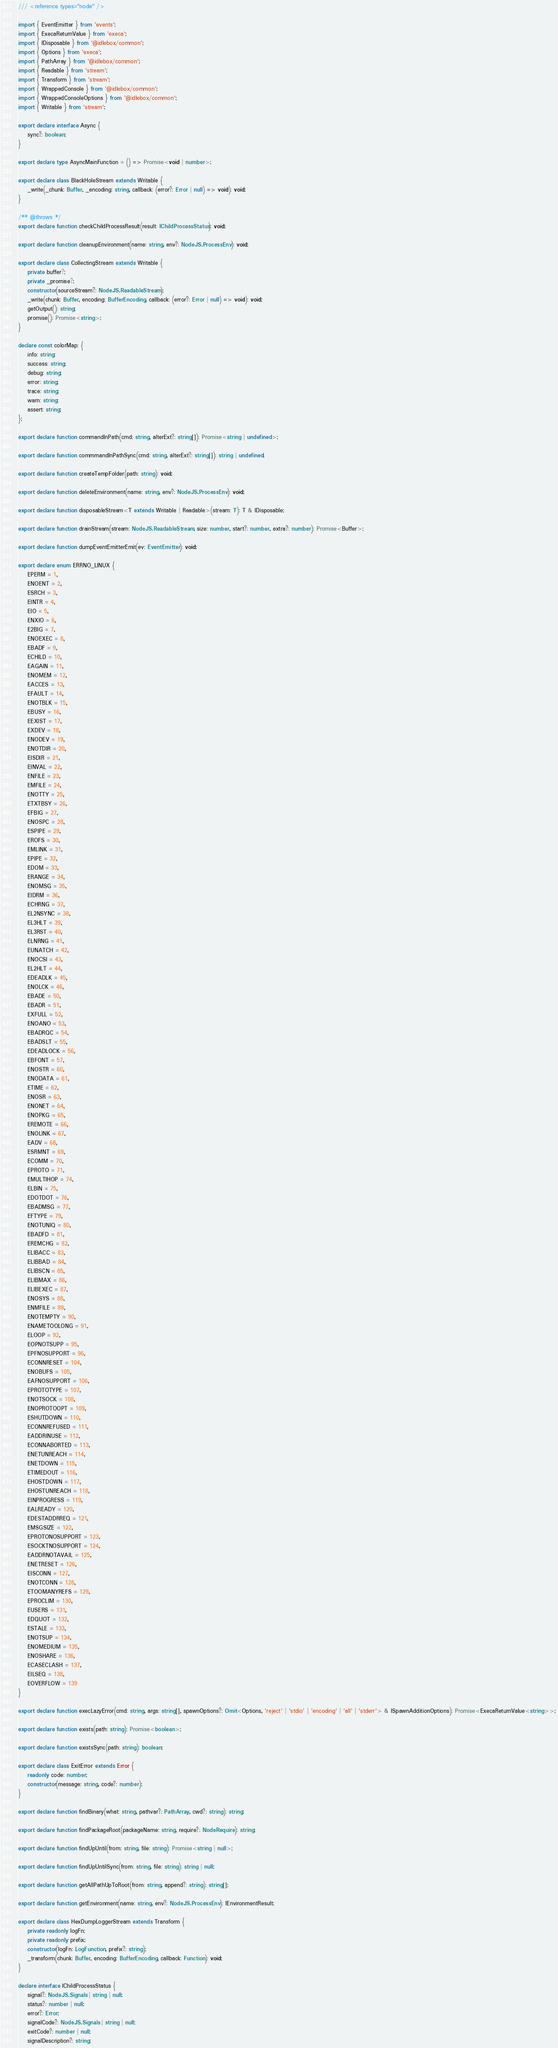Convert code to text. <code><loc_0><loc_0><loc_500><loc_500><_TypeScript_>/// <reference types="node" />

import { EventEmitter } from 'events';
import { ExecaReturnValue } from 'execa';
import { IDisposable } from '@idlebox/common';
import { Options } from 'execa';
import { PathArray } from '@idlebox/common';
import { Readable } from 'stream';
import { Transform } from 'stream';
import { WrappedConsole } from '@idlebox/common';
import { WrappedConsoleOptions } from '@idlebox/common';
import { Writable } from 'stream';

export declare interface Async {
    sync?: boolean;
}

export declare type AsyncMainFunction = () => Promise<void | number>;

export declare class BlackHoleStream extends Writable {
    _write(_chunk: Buffer, _encoding: string, callback: (error?: Error | null) => void): void;
}

/** @throws */
export declare function checkChildProcessResult(result: IChildProcessStatus): void;

export declare function cleanupEnvironment(name: string, env?: NodeJS.ProcessEnv): void;

export declare class CollectingStream extends Writable {
    private buffer?;
    private _promise?;
    constructor(sourceStream?: NodeJS.ReadableStream);
    _write(chunk: Buffer, encoding: BufferEncoding, callback: (error?: Error | null) => void): void;
    getOutput(): string;
    promise(): Promise<string>;
}

declare const colorMap: {
    info: string;
    success: string;
    debug: string;
    error: string;
    trace: string;
    warn: string;
    assert: string;
};

export declare function commandInPath(cmd: string, alterExt?: string[]): Promise<string | undefined>;

export declare function commmandInPathSync(cmd: string, alterExt?: string[]): string | undefined;

export declare function createTempFolder(path: string): void;

export declare function deleteEnvironment(name: string, env?: NodeJS.ProcessEnv): void;

export declare function disposableStream<T extends Writable | Readable>(stream: T): T & IDisposable;

export declare function drainStream(stream: NodeJS.ReadableStream, size: number, start?: number, extra?: number): Promise<Buffer>;

export declare function dumpEventEmitterEmit(ev: EventEmitter): void;

export declare enum ERRNO_LINUX {
    EPERM = 1,
    ENOENT = 2,
    ESRCH = 3,
    EINTR = 4,
    EIO = 5,
    ENXIO = 6,
    E2BIG = 7,
    ENOEXEC = 8,
    EBADF = 9,
    ECHILD = 10,
    EAGAIN = 11,
    ENOMEM = 12,
    EACCES = 13,
    EFAULT = 14,
    ENOTBLK = 15,
    EBUSY = 16,
    EEXIST = 17,
    EXDEV = 18,
    ENODEV = 19,
    ENOTDIR = 20,
    EISDIR = 21,
    EINVAL = 22,
    ENFILE = 23,
    EMFILE = 24,
    ENOTTY = 25,
    ETXTBSY = 26,
    EFBIG = 27,
    ENOSPC = 28,
    ESPIPE = 29,
    EROFS = 30,
    EMLINK = 31,
    EPIPE = 32,
    EDOM = 33,
    ERANGE = 34,
    ENOMSG = 35,
    EIDRM = 36,
    ECHRNG = 37,
    EL2NSYNC = 38,
    EL3HLT = 39,
    EL3RST = 40,
    ELNRNG = 41,
    EUNATCH = 42,
    ENOCSI = 43,
    EL2HLT = 44,
    EDEADLK = 45,
    ENOLCK = 46,
    EBADE = 50,
    EBADR = 51,
    EXFULL = 52,
    ENOANO = 53,
    EBADRQC = 54,
    EBADSLT = 55,
    EDEADLOCK = 56,
    EBFONT = 57,
    ENOSTR = 60,
    ENODATA = 61,
    ETIME = 62,
    ENOSR = 63,
    ENONET = 64,
    ENOPKG = 65,
    EREMOTE = 66,
    ENOLINK = 67,
    EADV = 68,
    ESRMNT = 69,
    ECOMM = 70,
    EPROTO = 71,
    EMULTIHOP = 74,
    ELBIN = 75,
    EDOTDOT = 76,
    EBADMSG = 77,
    EFTYPE = 79,
    ENOTUNIQ = 80,
    EBADFD = 81,
    EREMCHG = 82,
    ELIBACC = 83,
    ELIBBAD = 84,
    ELIBSCN = 85,
    ELIBMAX = 86,
    ELIBEXEC = 87,
    ENOSYS = 88,
    ENMFILE = 89,
    ENOTEMPTY = 90,
    ENAMETOOLONG = 91,
    ELOOP = 92,
    EOPNOTSUPP = 95,
    EPFNOSUPPORT = 96,
    ECONNRESET = 104,
    ENOBUFS = 105,
    EAFNOSUPPORT = 106,
    EPROTOTYPE = 107,
    ENOTSOCK = 108,
    ENOPROTOOPT = 109,
    ESHUTDOWN = 110,
    ECONNREFUSED = 111,
    EADDRINUSE = 112,
    ECONNABORTED = 113,
    ENETUNREACH = 114,
    ENETDOWN = 115,
    ETIMEDOUT = 116,
    EHOSTDOWN = 117,
    EHOSTUNREACH = 118,
    EINPROGRESS = 119,
    EALREADY = 120,
    EDESTADDRREQ = 121,
    EMSGSIZE = 122,
    EPROTONOSUPPORT = 123,
    ESOCKTNOSUPPORT = 124,
    EADDRNOTAVAIL = 125,
    ENETRESET = 126,
    EISCONN = 127,
    ENOTCONN = 128,
    ETOOMANYREFS = 129,
    EPROCLIM = 130,
    EUSERS = 131,
    EDQUOT = 132,
    ESTALE = 133,
    ENOTSUP = 134,
    ENOMEDIUM = 135,
    ENOSHARE = 136,
    ECASECLASH = 137,
    EILSEQ = 138,
    EOVERFLOW = 139
}

export declare function execLazyError(cmd: string, args: string[], spawnOptions?: Omit<Options, 'reject' | 'stdio' | 'encoding' | 'all' | 'stderr'> & ISpawnAdditionOptions): Promise<ExecaReturnValue<string>>;

export declare function exists(path: string): Promise<boolean>;

export declare function existsSync(path: string): boolean;

export declare class ExitError extends Error {
    readonly code: number;
    constructor(message: string, code?: number);
}

export declare function findBinary(what: string, pathvar?: PathArray, cwd?: string): string;

export declare function findPackageRoot(packageName: string, require?: NodeRequire): string;

export declare function findUpUntil(from: string, file: string): Promise<string | null>;

export declare function findUpUntilSync(from: string, file: string): string | null;

export declare function getAllPathUpToRoot(from: string, append?: string): string[];

export declare function getEnvironment(name: string, env?: NodeJS.ProcessEnv): IEnvironmentResult;

export declare class HexDumpLoggerStream extends Transform {
    private readonly logFn;
    private readonly prefix;
    constructor(logFn: LogFunction, prefix?: string);
    _transform(chunk: Buffer, encoding: BufferEncoding, callback: Function): void;
}

declare interface IChildProcessStatus {
    signal?: NodeJS.Signals | string | null;
    status?: number | null;
    error?: Error;
    signalCode?: NodeJS.Signals | string | null;
    exitCode?: number | null;
    signalDescription?: string;</code> 